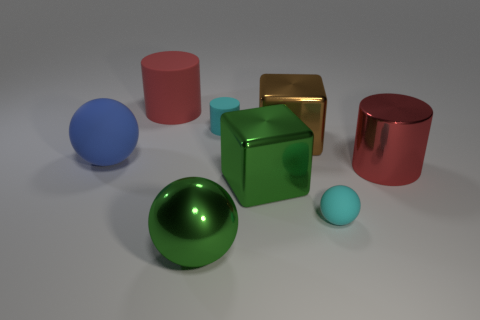What number of matte cylinders have the same color as the large shiny cylinder? There is one matte cylinder that has the same color as the large shiny cylinder, which is a vibrant shade of green. 